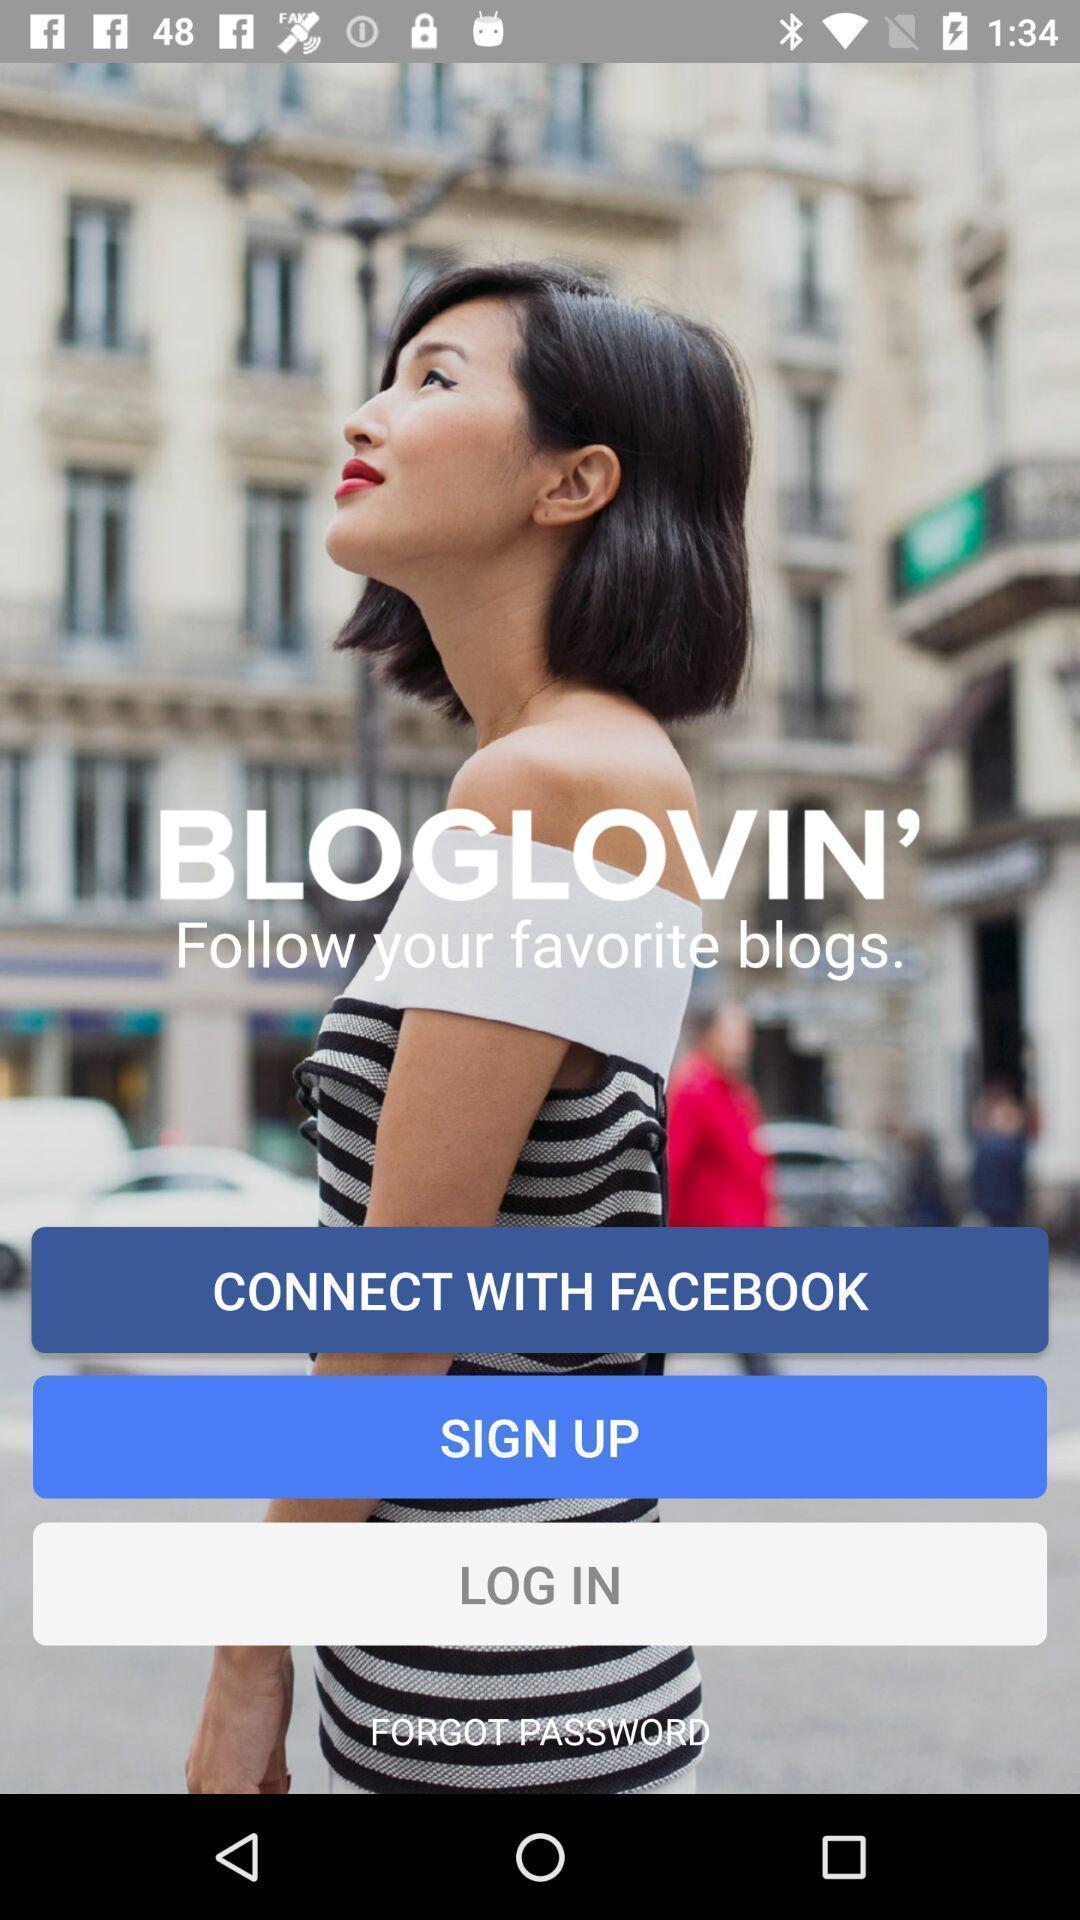Describe the content in this image. Welcome page with options for a blogging related app. 